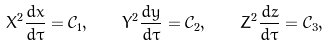<formula> <loc_0><loc_0><loc_500><loc_500>X ^ { 2 } \frac { d x } { d \tau } = \mathcal { C } _ { 1 } , \quad Y ^ { 2 } \frac { d y } { d \tau } = \mathcal { C } _ { 2 } , \quad Z ^ { 2 } \frac { d z } { d \tau } = \mathcal { C } _ { 3 } ,</formula> 